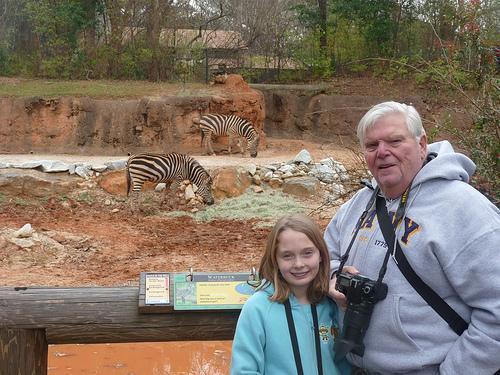How many people are seen?
Give a very brief answer. 2. How many zebras are at the zoo?
Give a very brief answer. 2. How many zebras are taking pictures the people?
Give a very brief answer. 0. 